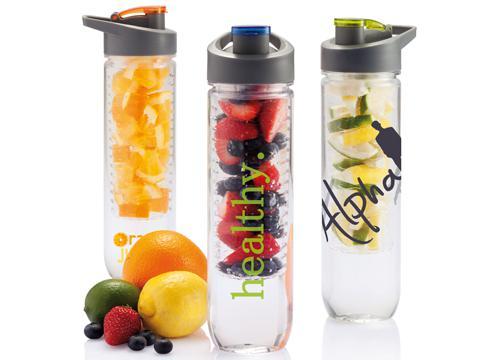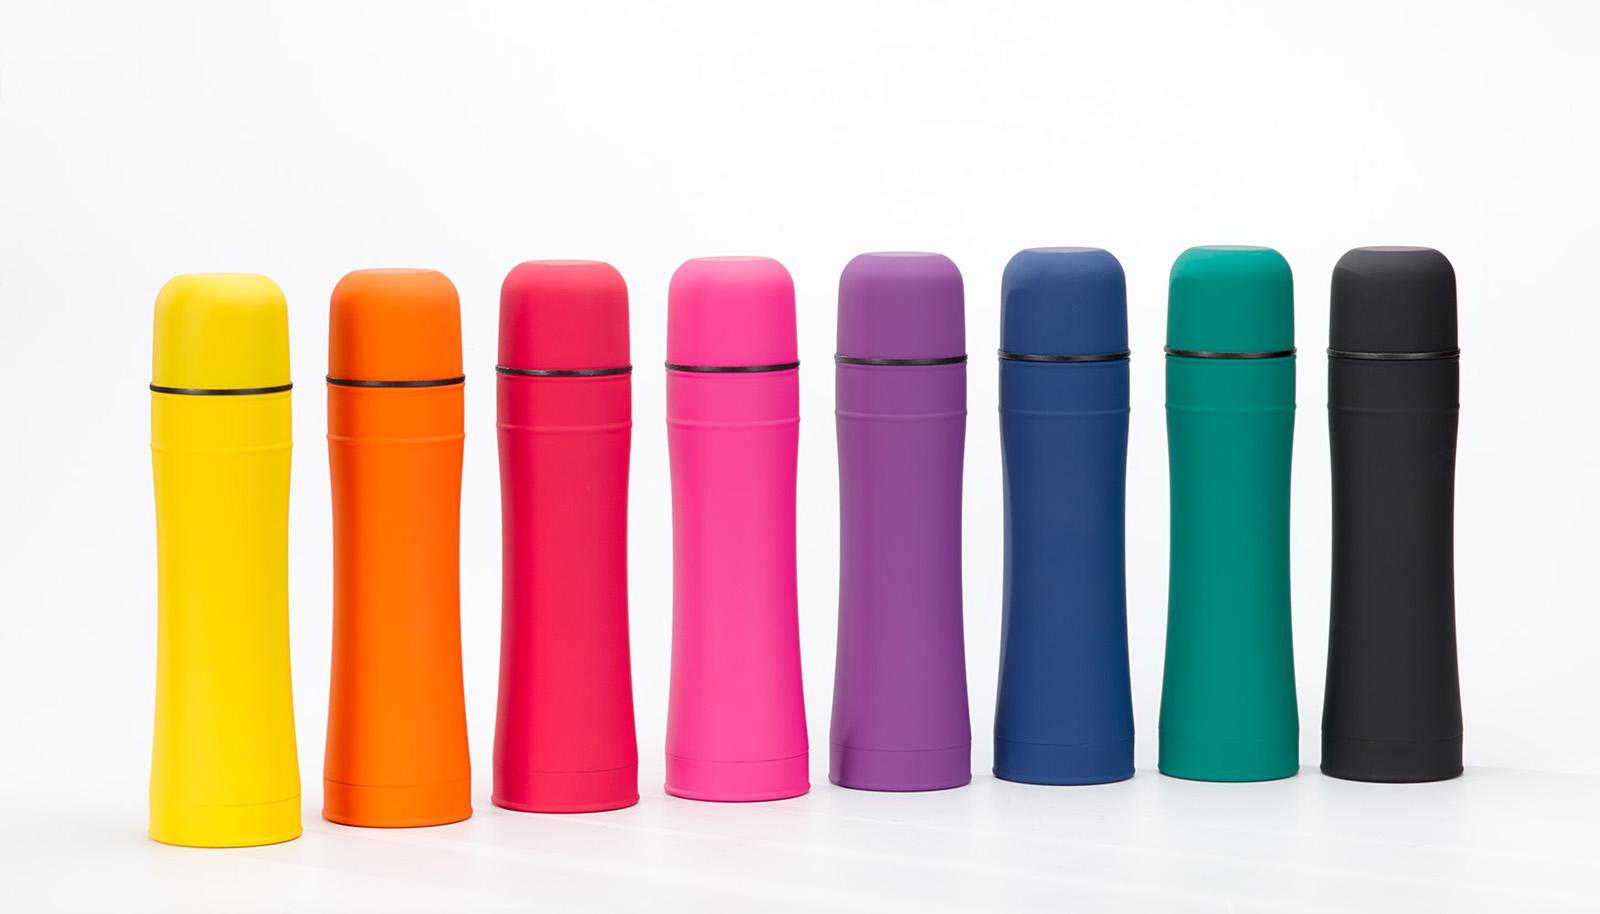The first image is the image on the left, the second image is the image on the right. Examine the images to the left and right. Is the description "There are two green bottles." accurate? Answer yes or no. No. 